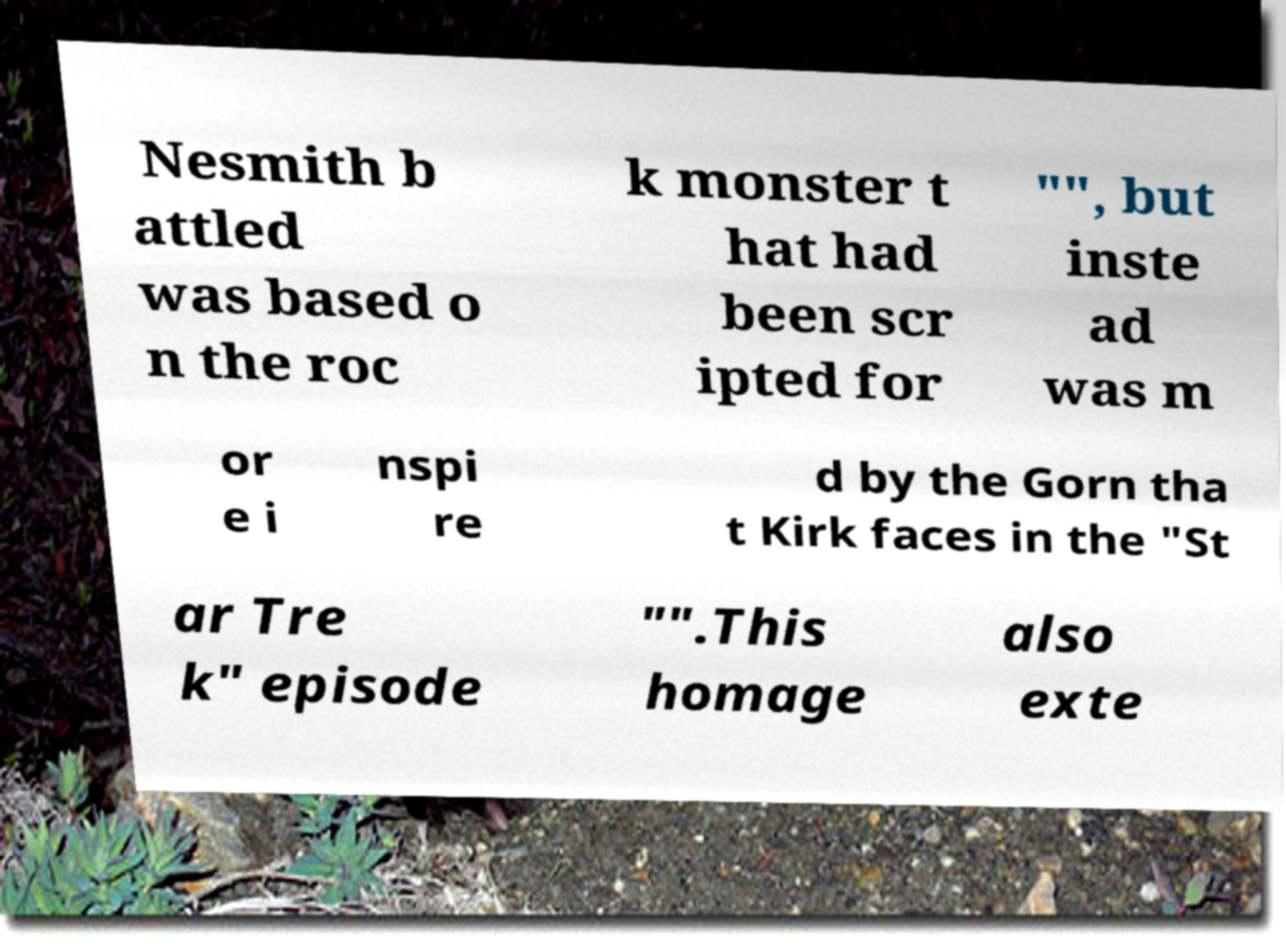Could you assist in decoding the text presented in this image and type it out clearly? Nesmith b attled was based o n the roc k monster t hat had been scr ipted for "", but inste ad was m or e i nspi re d by the Gorn tha t Kirk faces in the "St ar Tre k" episode "".This homage also exte 